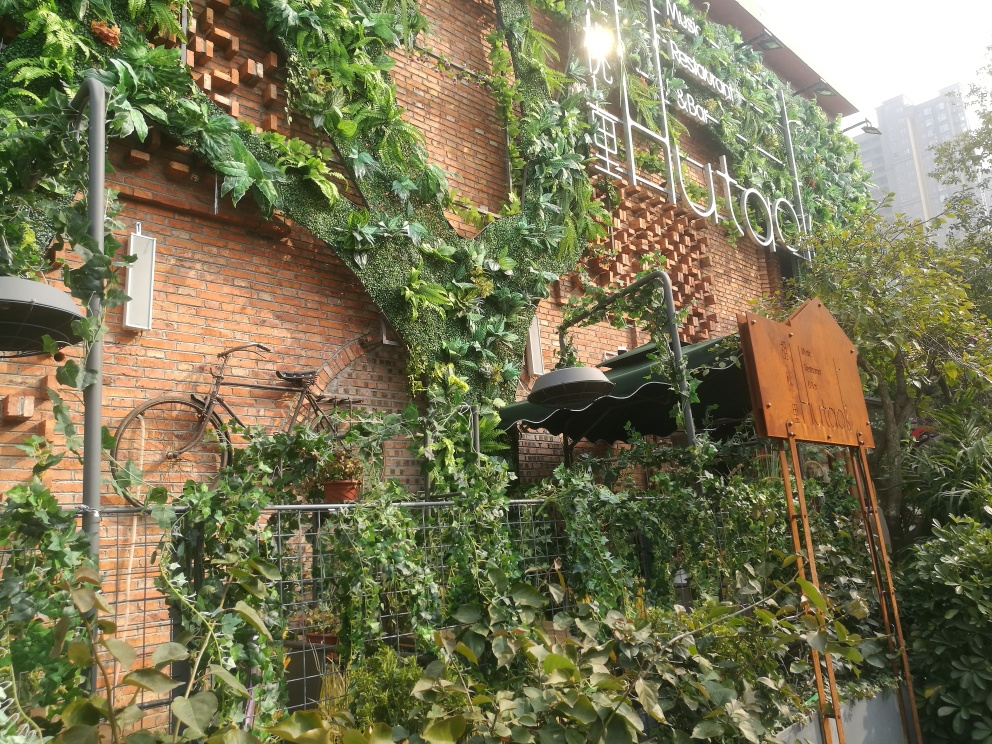Is the texture of the wall clear? The wall texture is quite clear, showing a mix of red bricks partially obscured by green ivy that gives a rustic and lively appearance. The interplay of foliage against the brick provides a compelling and intricate visual texture. 